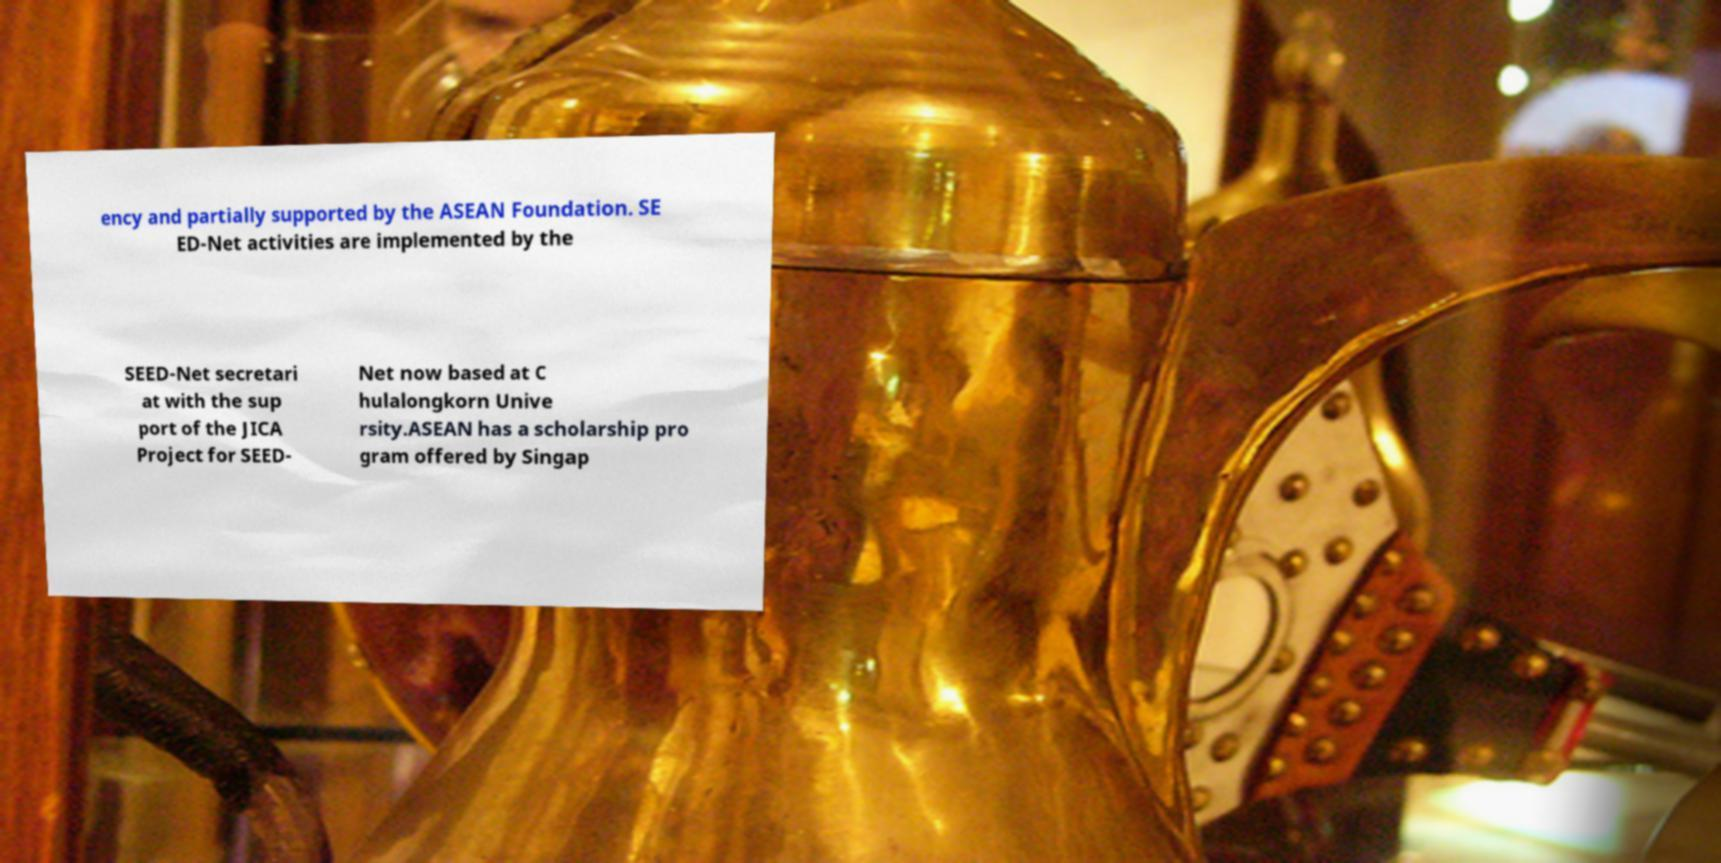For documentation purposes, I need the text within this image transcribed. Could you provide that? ency and partially supported by the ASEAN Foundation. SE ED-Net activities are implemented by the SEED-Net secretari at with the sup port of the JICA Project for SEED- Net now based at C hulalongkorn Unive rsity.ASEAN has a scholarship pro gram offered by Singap 